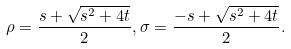Convert formula to latex. <formula><loc_0><loc_0><loc_500><loc_500>\rho = \frac { s + \sqrt { s ^ { 2 } + 4 t } } { 2 } , \sigma = \frac { - s + \sqrt { s ^ { 2 } + 4 t } } { 2 } .</formula> 